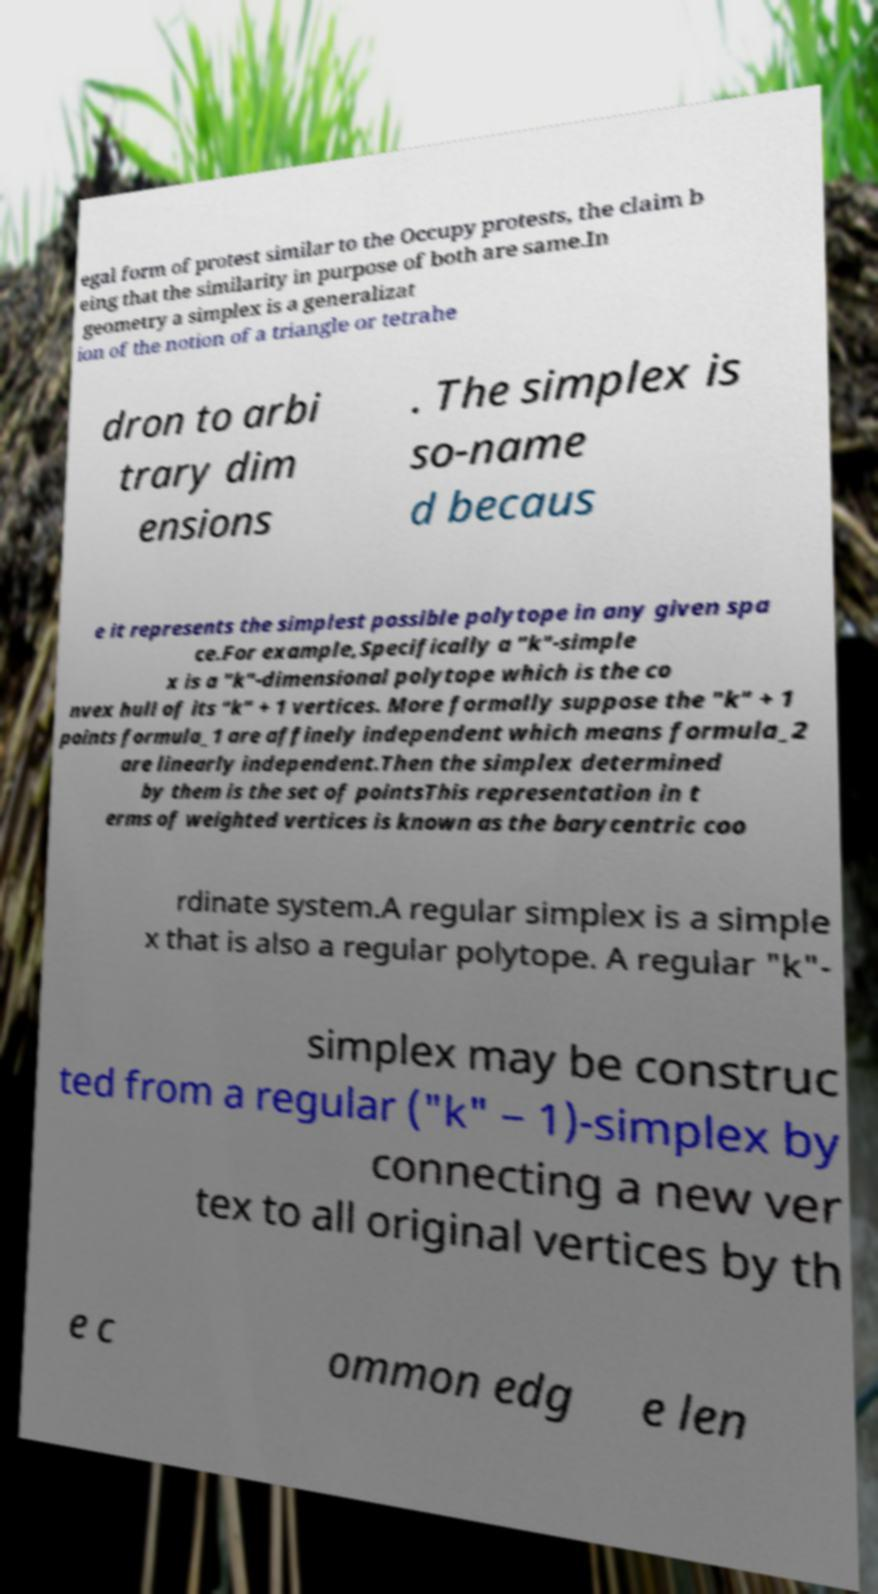Please identify and transcribe the text found in this image. egal form of protest similar to the Occupy protests, the claim b eing that the similarity in purpose of both are same.In geometry a simplex is a generalizat ion of the notion of a triangle or tetrahe dron to arbi trary dim ensions . The simplex is so-name d becaus e it represents the simplest possible polytope in any given spa ce.For example,Specifically a "k"-simple x is a "k"-dimensional polytope which is the co nvex hull of its "k" + 1 vertices. More formally suppose the "k" + 1 points formula_1 are affinely independent which means formula_2 are linearly independent.Then the simplex determined by them is the set of pointsThis representation in t erms of weighted vertices is known as the barycentric coo rdinate system.A regular simplex is a simple x that is also a regular polytope. A regular "k"- simplex may be construc ted from a regular ("k" − 1)-simplex by connecting a new ver tex to all original vertices by th e c ommon edg e len 